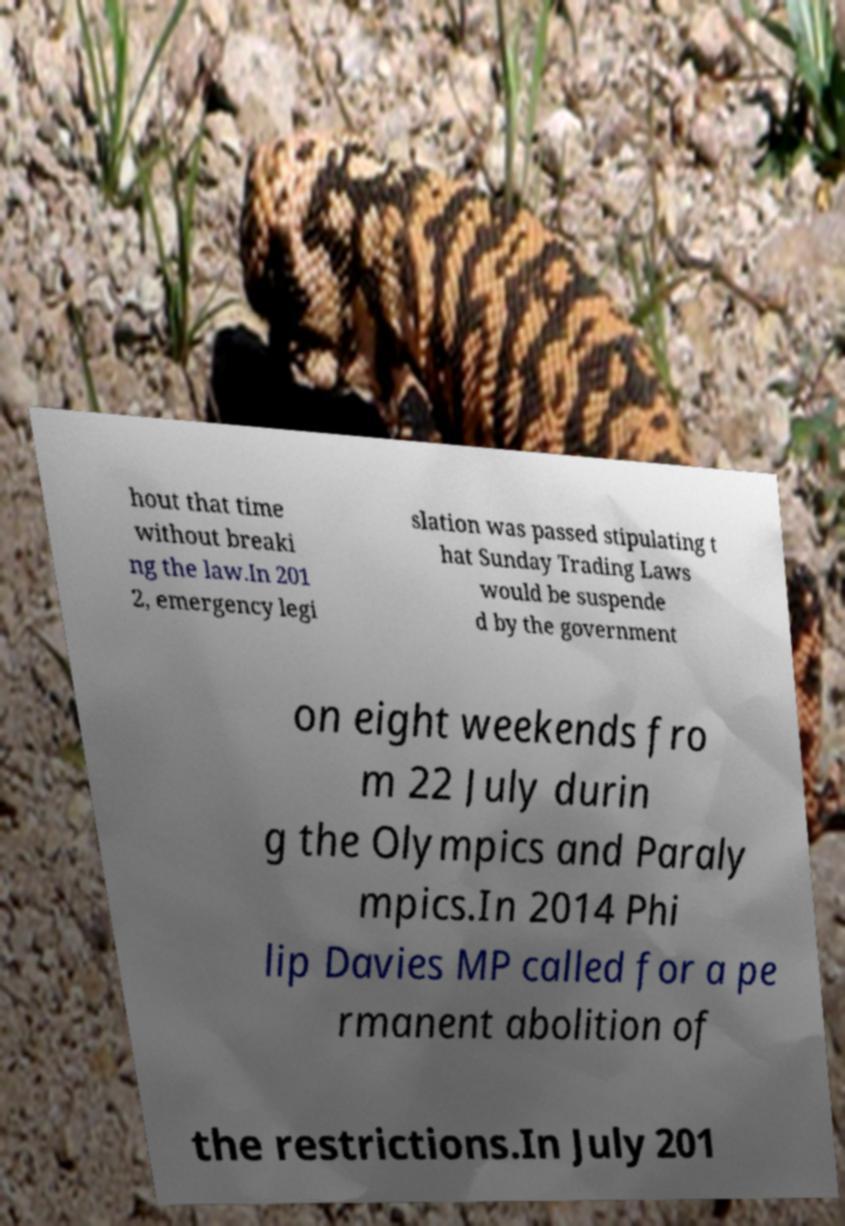Please read and relay the text visible in this image. What does it say? hout that time without breaki ng the law.In 201 2, emergency legi slation was passed stipulating t hat Sunday Trading Laws would be suspende d by the government on eight weekends fro m 22 July durin g the Olympics and Paraly mpics.In 2014 Phi lip Davies MP called for a pe rmanent abolition of the restrictions.In July 201 